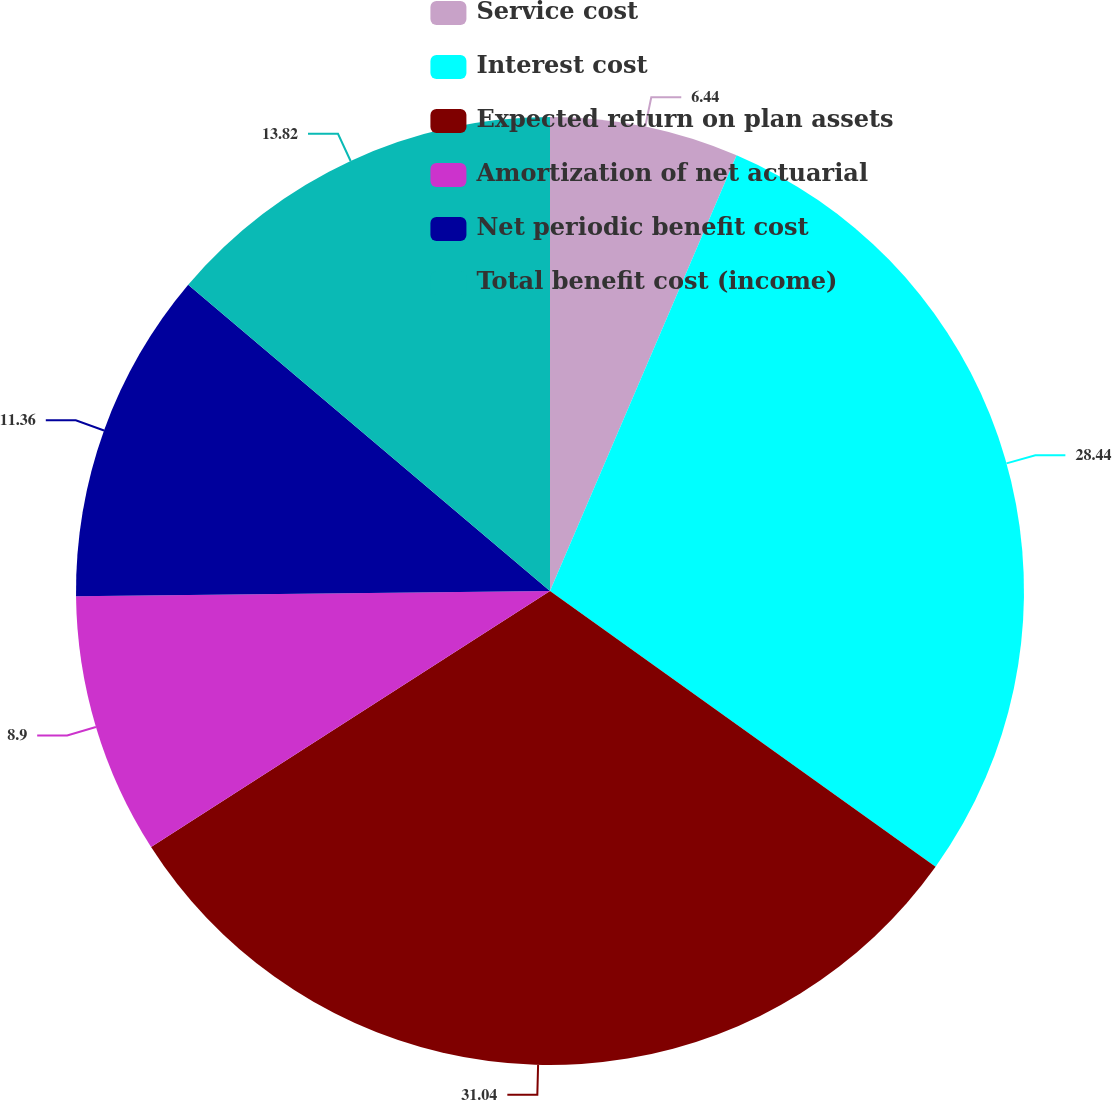Convert chart. <chart><loc_0><loc_0><loc_500><loc_500><pie_chart><fcel>Service cost<fcel>Interest cost<fcel>Expected return on plan assets<fcel>Amortization of net actuarial<fcel>Net periodic benefit cost<fcel>Total benefit cost (income)<nl><fcel>6.44%<fcel>28.44%<fcel>31.04%<fcel>8.9%<fcel>11.36%<fcel>13.82%<nl></chart> 